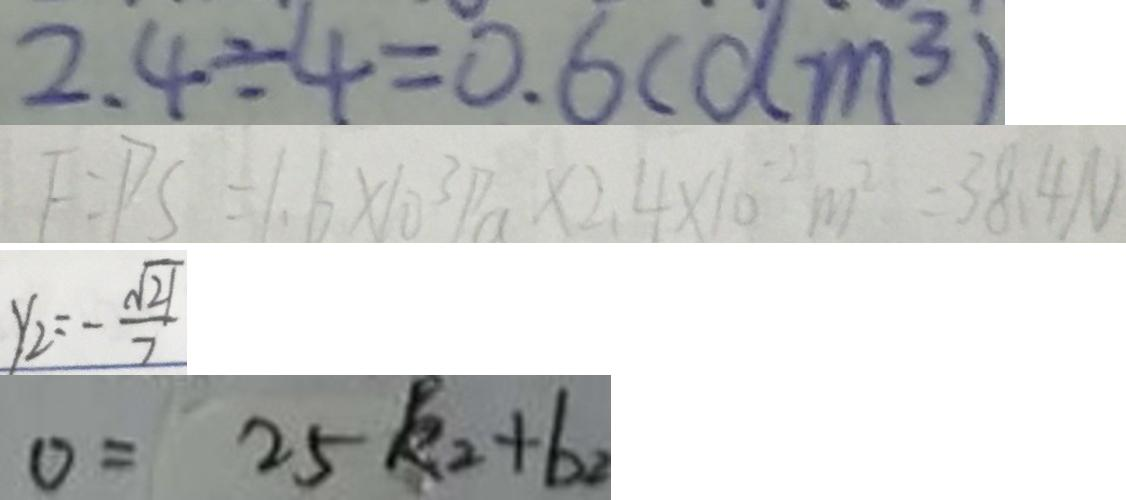Convert formula to latex. <formula><loc_0><loc_0><loc_500><loc_500>2 . 4 \div 4 = 0 . 6 ( d m ^ { 3 } ) 
 F = P S = 1 . 6 \times 1 0 ^ { 3 } P a \times 2 . 4 \times 1 0 ^ { - 2 } m ^ { 2 } = 3 8 . 4 N 
 y _ { 2 } = - \frac { \sqrt { 2 1 } } { 7 } 
 0 = 2 5 k _ { 2 } + b _ { 2 }</formula> 